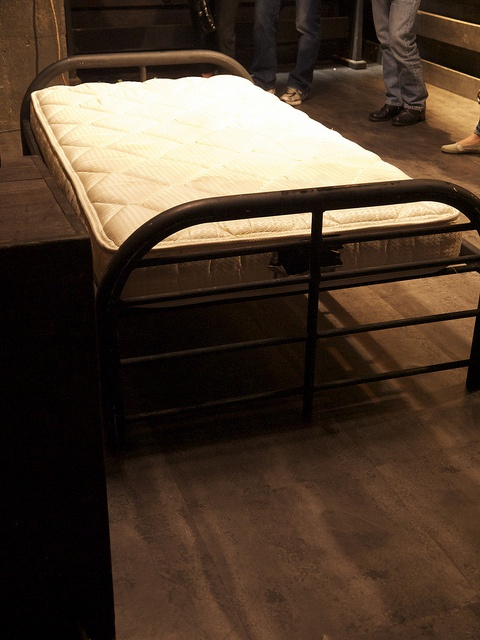Describe the objects in this image and their specific colors. I can see bed in black, beige, tan, and maroon tones, people in black, gray, and maroon tones, people in black, gray, and maroon tones, and people in black, tan, brown, and maroon tones in this image. 